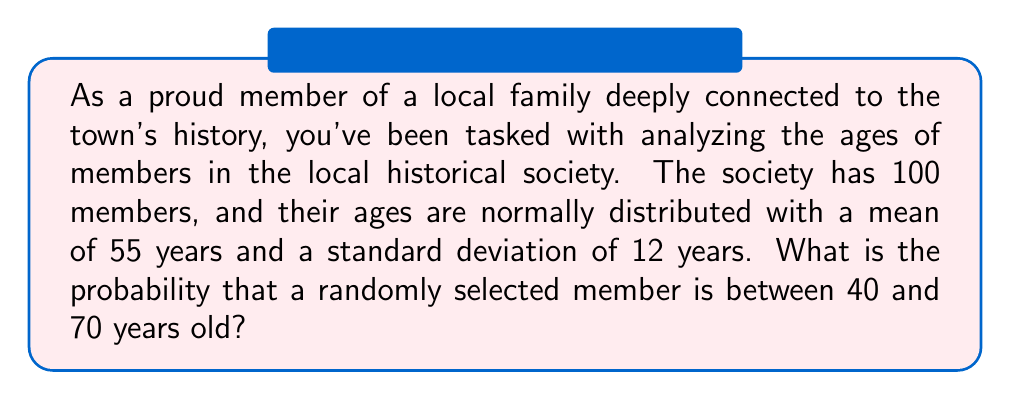Provide a solution to this math problem. To solve this problem, we'll use the properties of the normal distribution and the z-score formula.

Step 1: Identify the given information
- The ages are normally distributed
- Mean (μ) = 55 years
- Standard deviation (σ) = 12 years
- We want to find P(40 < X < 70), where X is the age of a randomly selected member

Step 2: Calculate the z-scores for the lower and upper bounds
For the lower bound (40 years):
$z_1 = \frac{x - \mu}{\sigma} = \frac{40 - 55}{12} = -1.25$

For the upper bound (70 years):
$z_2 = \frac{x - \mu}{\sigma} = \frac{70 - 55}{12} = 1.25$

Step 3: Use the standard normal distribution table or calculator to find the area under the curve between these z-scores

The probability is equal to the area between z = -1.25 and z = 1.25 in a standard normal distribution.

P(40 < X < 70) = P(-1.25 < Z < 1.25)
               = P(Z < 1.25) - P(Z < -1.25)
               = 0.8944 - 0.1056
               = 0.7888

Step 4: Convert the result to a percentage
0.7888 * 100 = 78.88%

Therefore, the probability that a randomly selected member is between 40 and 70 years old is approximately 78.88%.
Answer: 78.88% 